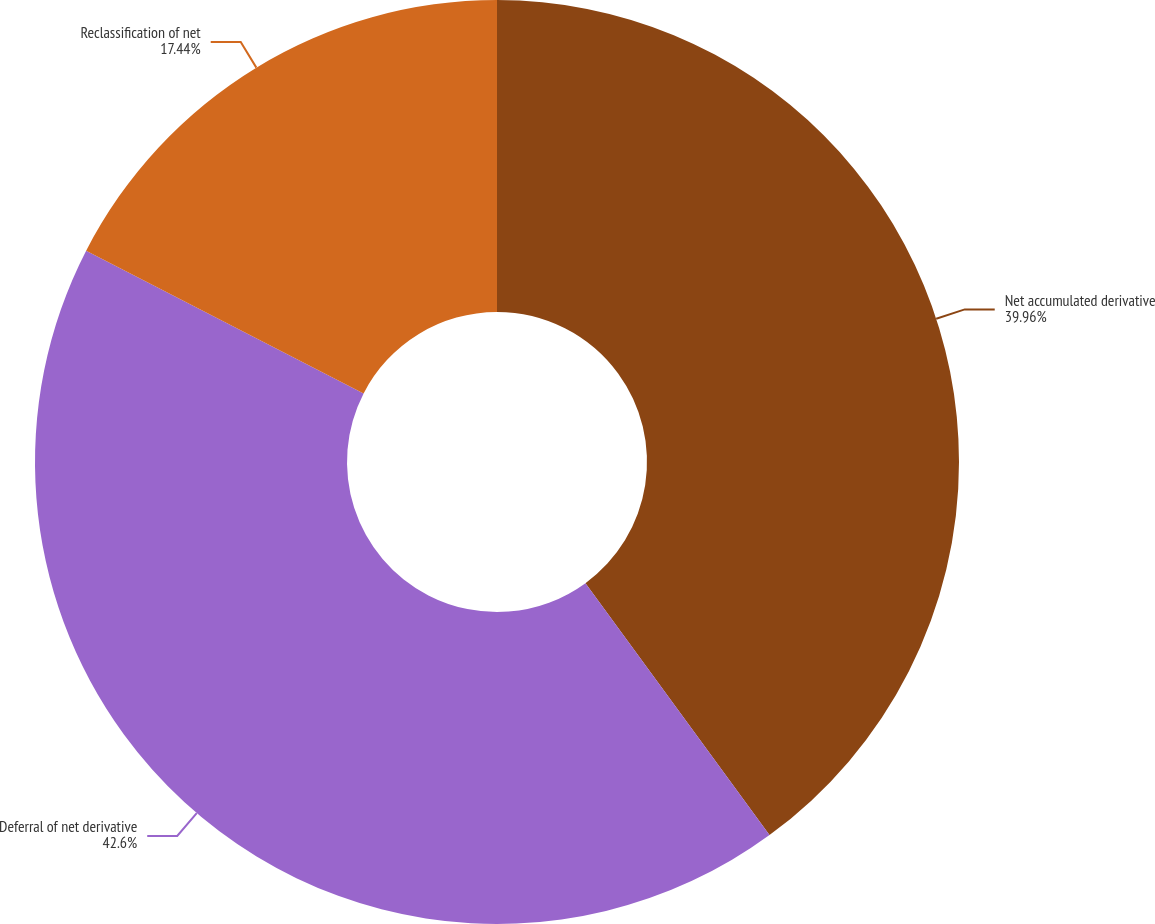Convert chart. <chart><loc_0><loc_0><loc_500><loc_500><pie_chart><fcel>Net accumulated derivative<fcel>Deferral of net derivative<fcel>Reclassification of net<nl><fcel>39.96%<fcel>42.6%<fcel>17.44%<nl></chart> 